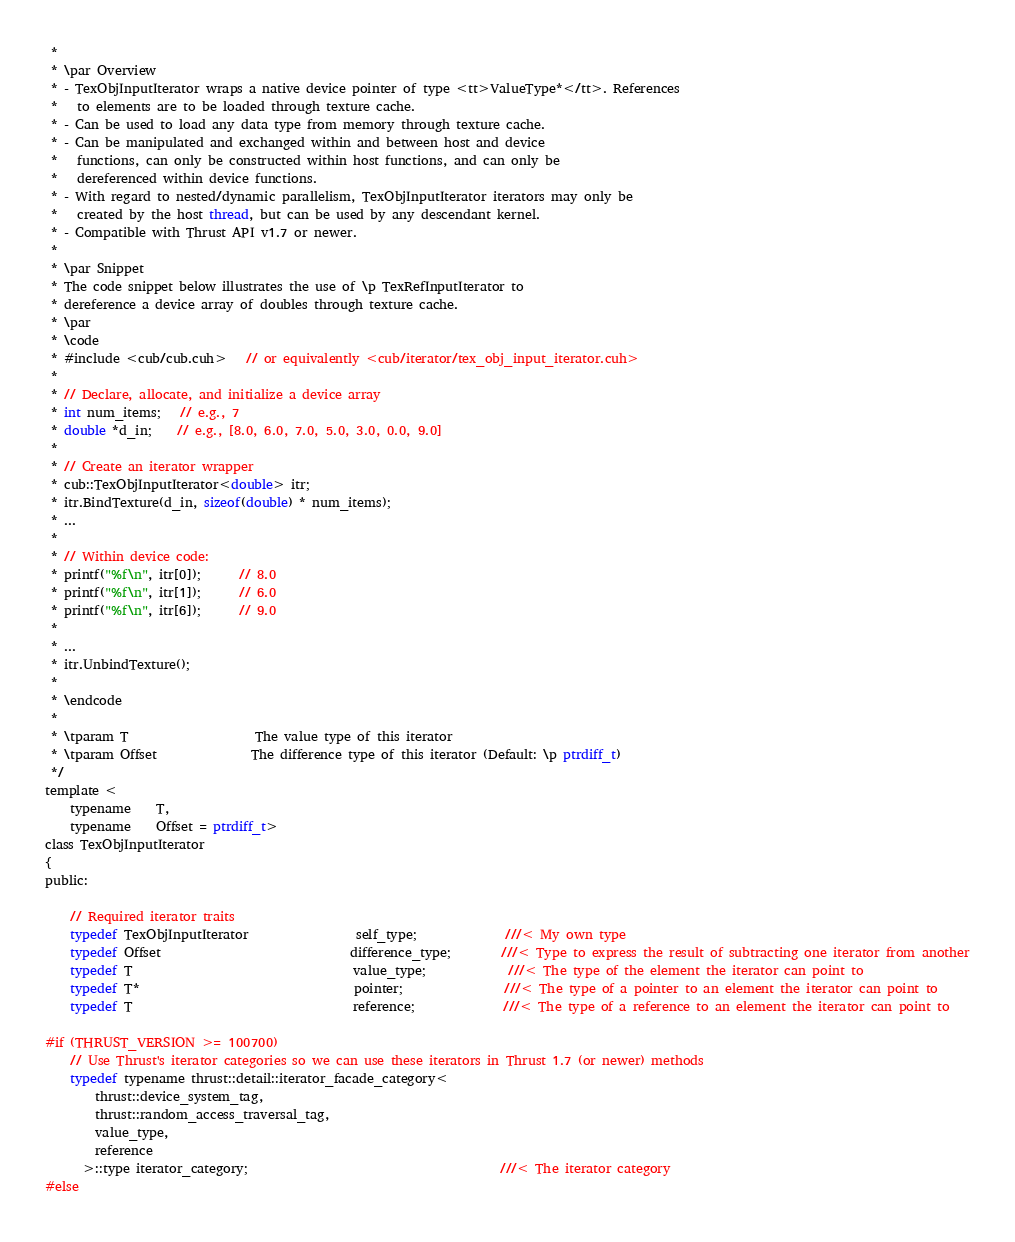<code> <loc_0><loc_0><loc_500><loc_500><_Cuda_> *
 * \par Overview
 * - TexObjInputIterator wraps a native device pointer of type <tt>ValueType*</tt>. References
 *   to elements are to be loaded through texture cache.
 * - Can be used to load any data type from memory through texture cache.
 * - Can be manipulated and exchanged within and between host and device
 *   functions, can only be constructed within host functions, and can only be
 *   dereferenced within device functions.
 * - With regard to nested/dynamic parallelism, TexObjInputIterator iterators may only be
 *   created by the host thread, but can be used by any descendant kernel.
 * - Compatible with Thrust API v1.7 or newer.
 *
 * \par Snippet
 * The code snippet below illustrates the use of \p TexRefInputIterator to
 * dereference a device array of doubles through texture cache.
 * \par
 * \code
 * #include <cub/cub.cuh>   // or equivalently <cub/iterator/tex_obj_input_iterator.cuh>
 *
 * // Declare, allocate, and initialize a device array
 * int num_items;   // e.g., 7
 * double *d_in;    // e.g., [8.0, 6.0, 7.0, 5.0, 3.0, 0.0, 9.0]
 *
 * // Create an iterator wrapper
 * cub::TexObjInputIterator<double> itr;
 * itr.BindTexture(d_in, sizeof(double) * num_items);
 * ...
 *
 * // Within device code:
 * printf("%f\n", itr[0]);      // 8.0
 * printf("%f\n", itr[1]);      // 6.0
 * printf("%f\n", itr[6]);      // 9.0
 *
 * ...
 * itr.UnbindTexture();
 *
 * \endcode
 *
 * \tparam T                    The value type of this iterator
 * \tparam Offset               The difference type of this iterator (Default: \p ptrdiff_t)
 */
template <
    typename    T,
    typename    Offset = ptrdiff_t>
class TexObjInputIterator
{
public:

    // Required iterator traits
    typedef TexObjInputIterator                 self_type;              ///< My own type
    typedef Offset                              difference_type;        ///< Type to express the result of subtracting one iterator from another
    typedef T                                   value_type;             ///< The type of the element the iterator can point to
    typedef T*                                  pointer;                ///< The type of a pointer to an element the iterator can point to
    typedef T                                   reference;              ///< The type of a reference to an element the iterator can point to

#if (THRUST_VERSION >= 100700)
    // Use Thrust's iterator categories so we can use these iterators in Thrust 1.7 (or newer) methods
    typedef typename thrust::detail::iterator_facade_category<
        thrust::device_system_tag,
        thrust::random_access_traversal_tag,
        value_type,
        reference
      >::type iterator_category;                                        ///< The iterator category
#else</code> 